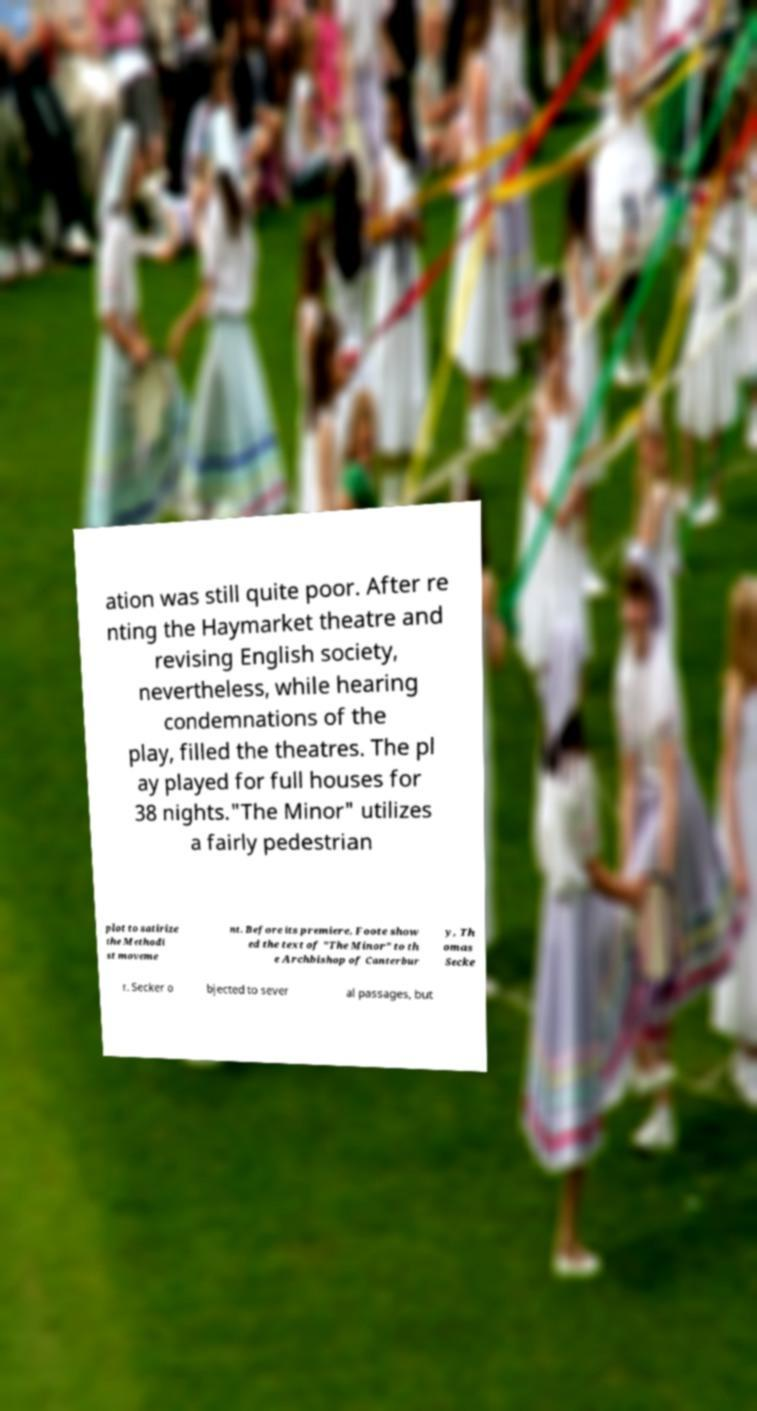There's text embedded in this image that I need extracted. Can you transcribe it verbatim? ation was still quite poor. After re nting the Haymarket theatre and revising English society, nevertheless, while hearing condemnations of the play, filled the theatres. The pl ay played for full houses for 38 nights."The Minor" utilizes a fairly pedestrian plot to satirize the Methodi st moveme nt. Before its premiere, Foote show ed the text of "The Minor" to th e Archbishop of Canterbur y, Th omas Secke r. Secker o bjected to sever al passages, but 